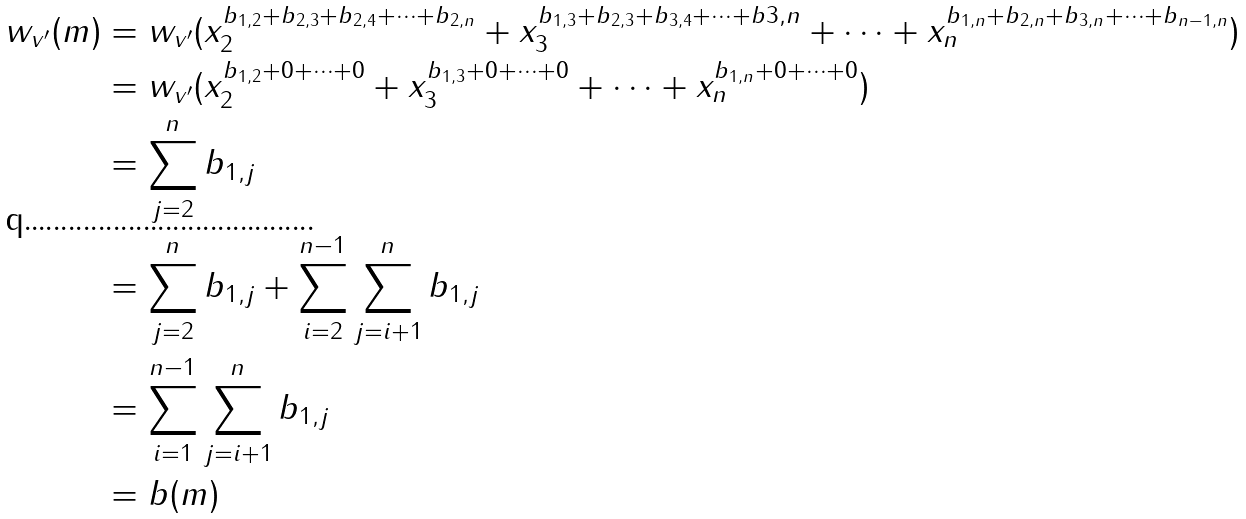Convert formula to latex. <formula><loc_0><loc_0><loc_500><loc_500>w _ { v ^ { \prime } } ( m ) & = w _ { v ^ { \prime } } ( x _ { 2 } ^ { b _ { 1 , 2 } + b _ { 2 , 3 } + b _ { 2 , 4 } + \dots + b _ { 2 , n } } + x _ { 3 } ^ { b _ { 1 , 3 } + b _ { 2 , 3 } + b _ { 3 , 4 } + \dots + b { 3 , n } } + \dots + x _ { n } ^ { b _ { 1 , n } + b _ { 2 , n } + b _ { 3 , n } + \dots + b _ { n - 1 , n } } ) \\ & = w _ { v ^ { \prime } } ( x _ { 2 } ^ { b _ { 1 , 2 } + 0 + \dots + 0 } + x _ { 3 } ^ { b _ { 1 , 3 } + 0 + \dots + 0 } + \dots + x _ { n } ^ { b _ { 1 , n } + 0 + \dots + 0 } ) \\ & = \sum _ { j = 2 } ^ { n } b _ { 1 , j } \\ & = \sum _ { j = 2 } ^ { n } b _ { 1 , j } + \sum _ { i = 2 } ^ { n - 1 } \sum _ { j = i + 1 } ^ { n } b _ { 1 , j } \\ & = \sum _ { i = 1 } ^ { n - 1 } \sum _ { j = i + 1 } ^ { n } b _ { 1 , j } \\ & = b ( m )</formula> 